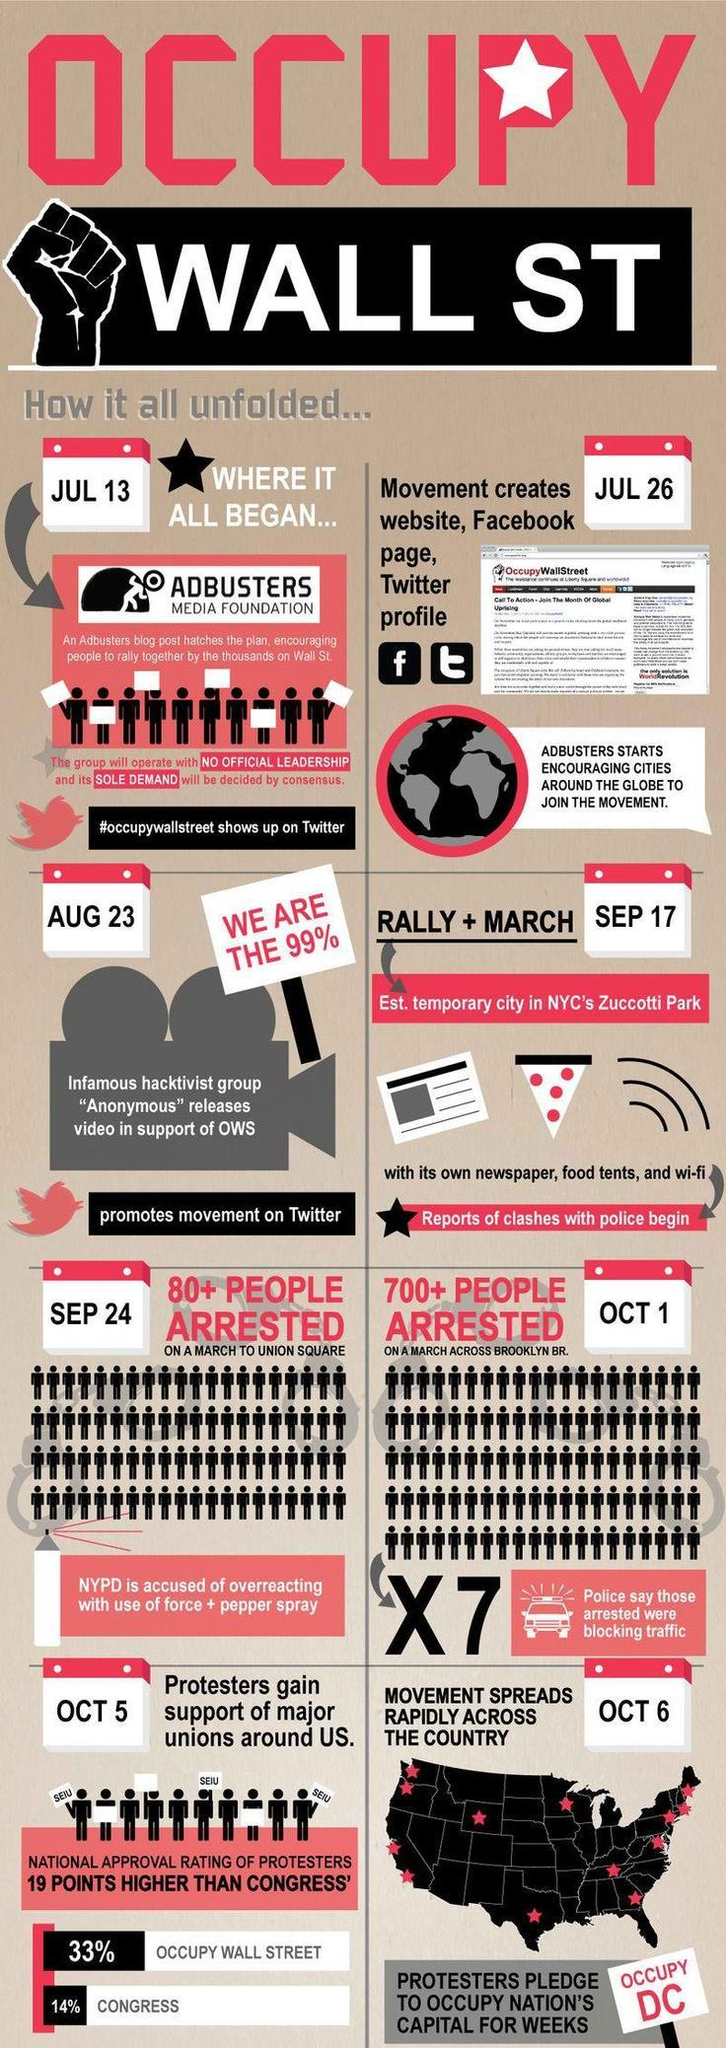What is the inverse percentage of people who do support Wall ST?
Answer the question with a short phrase. 67 What is so special about the Adbusters Media Foundation? No Official Leadership, Sole Demand When did the march to the Brooklyn branch happen? Oct 1 How many people got arrested on the march to the Brooklyn branch? 700+ people 